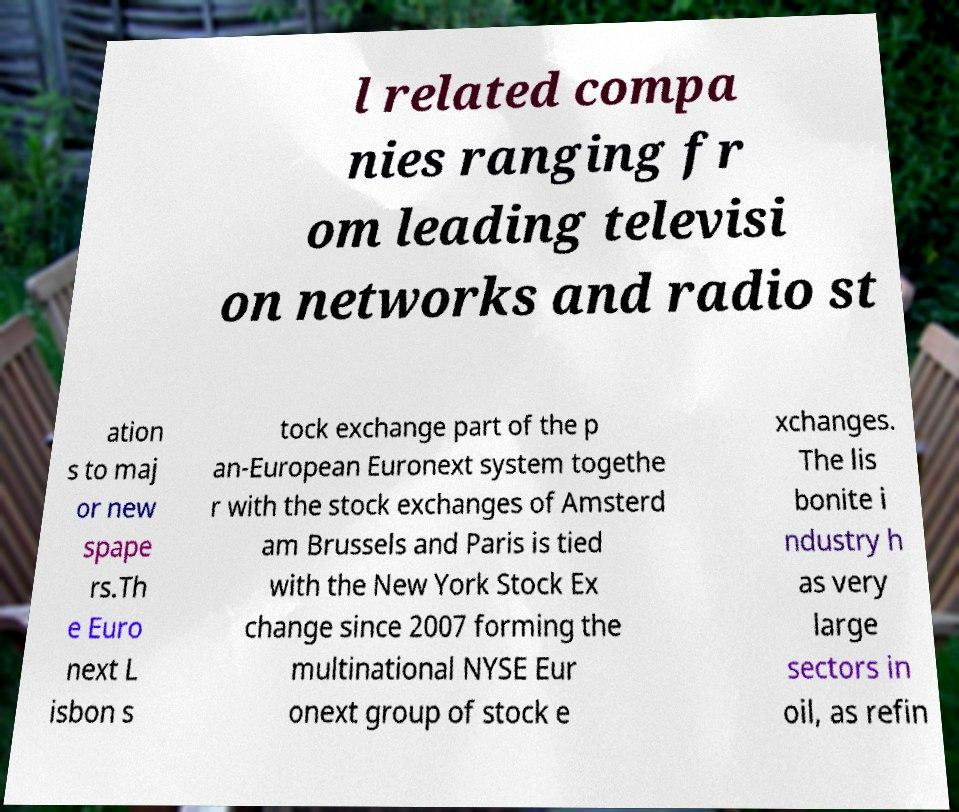Could you extract and type out the text from this image? l related compa nies ranging fr om leading televisi on networks and radio st ation s to maj or new spape rs.Th e Euro next L isbon s tock exchange part of the p an-European Euronext system togethe r with the stock exchanges of Amsterd am Brussels and Paris is tied with the New York Stock Ex change since 2007 forming the multinational NYSE Eur onext group of stock e xchanges. The lis bonite i ndustry h as very large sectors in oil, as refin 